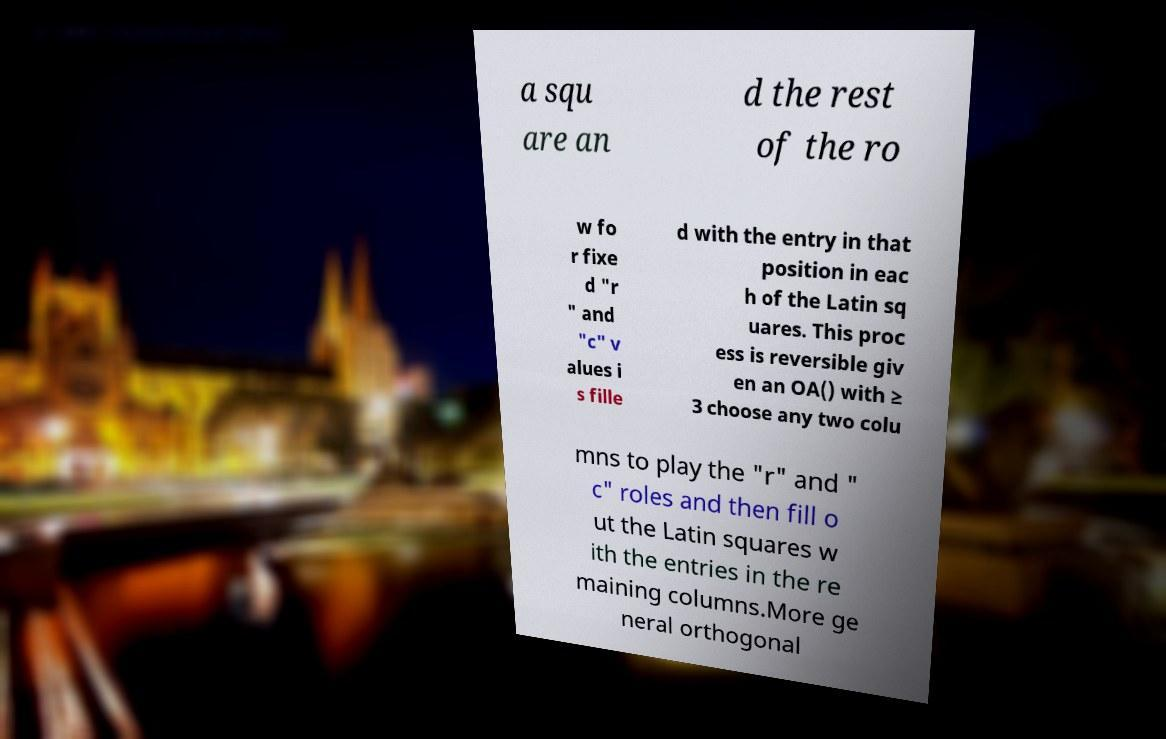Could you assist in decoding the text presented in this image and type it out clearly? a squ are an d the rest of the ro w fo r fixe d "r " and "c" v alues i s fille d with the entry in that position in eac h of the Latin sq uares. This proc ess is reversible giv en an OA() with ≥ 3 choose any two colu mns to play the "r" and " c" roles and then fill o ut the Latin squares w ith the entries in the re maining columns.More ge neral orthogonal 